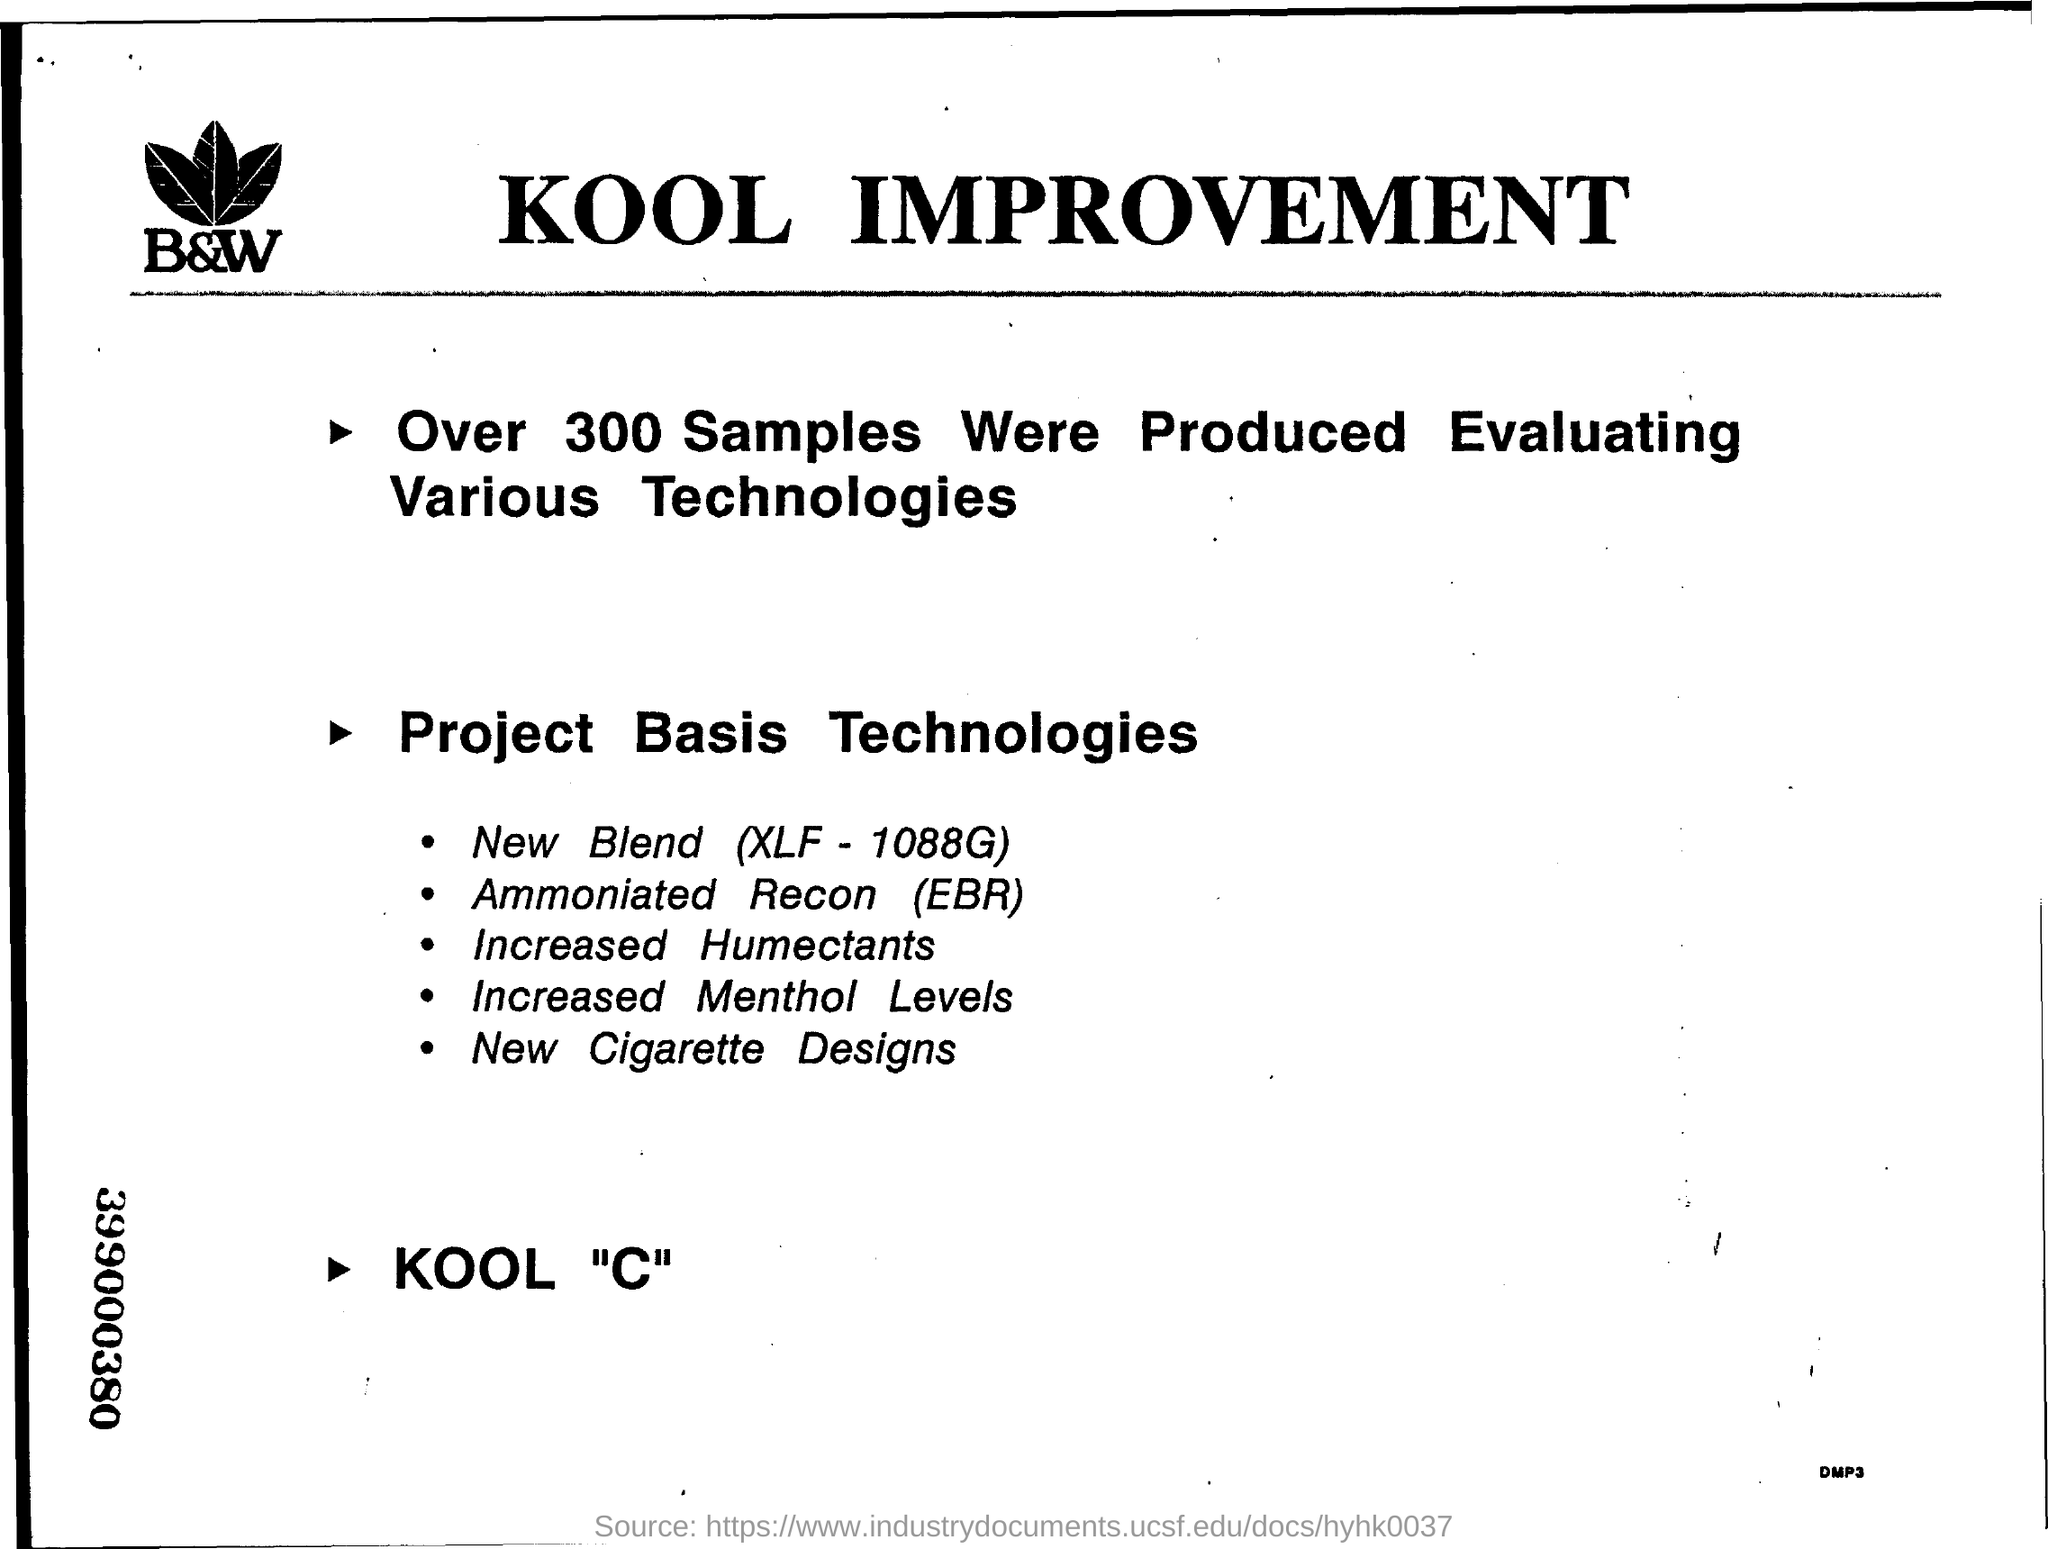Heading of the document?
Make the answer very short. Kool Improvement. How many samples were produced?
Make the answer very short. 300. What is the third point mentioned in Project Basis Technologies?
Your response must be concise. Increased Humectants. What is the 9 digits number mentioned on the left border at the bottom?
Your answer should be very brief. 399000380. 